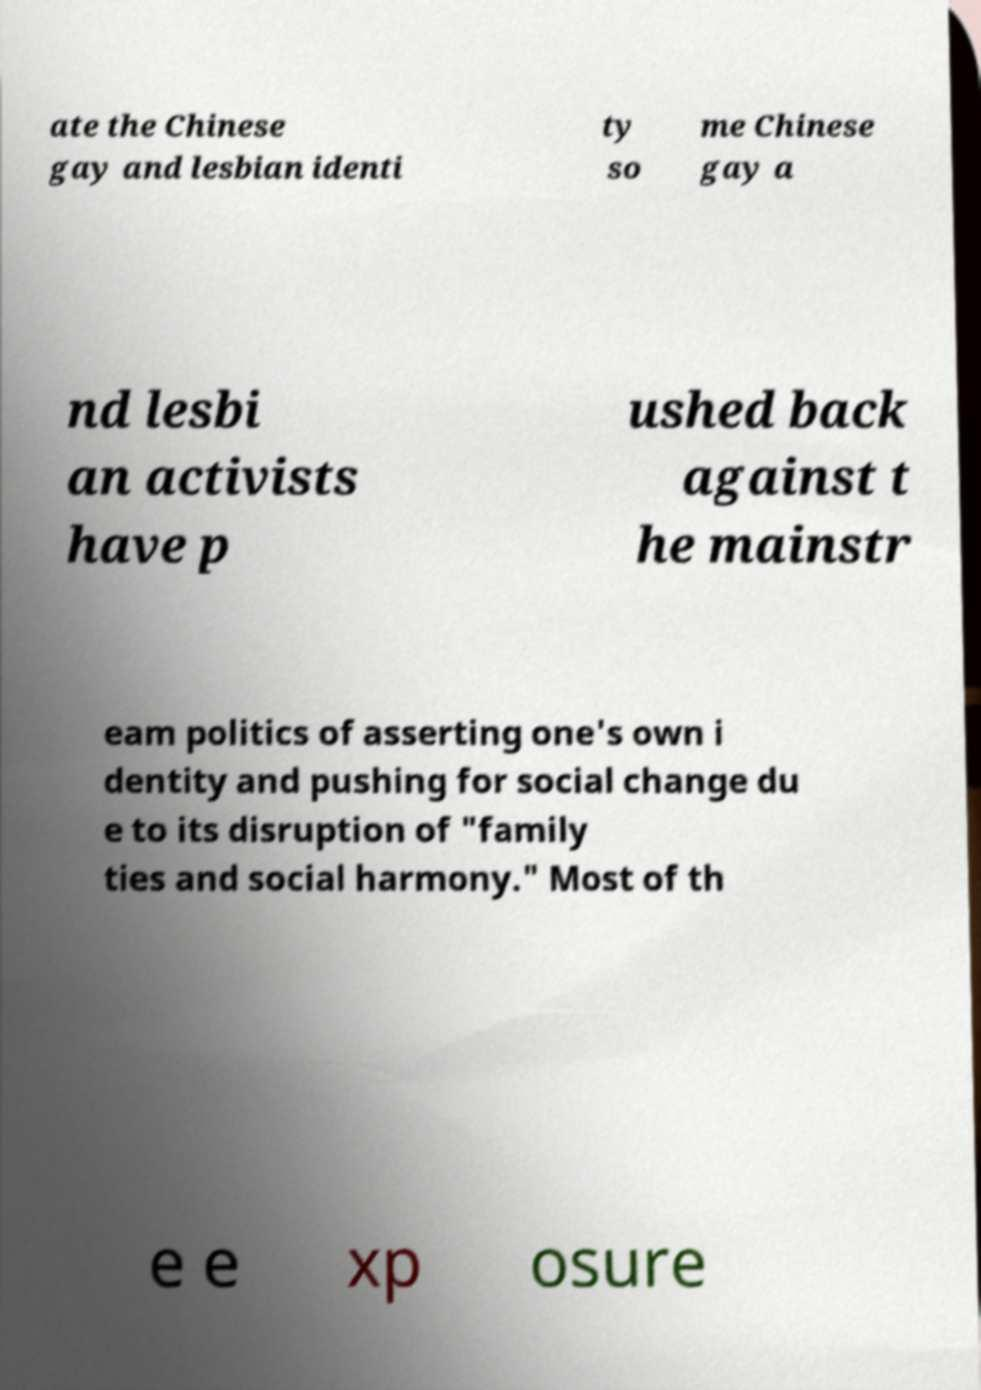Can you accurately transcribe the text from the provided image for me? ate the Chinese gay and lesbian identi ty so me Chinese gay a nd lesbi an activists have p ushed back against t he mainstr eam politics of asserting one's own i dentity and pushing for social change du e to its disruption of "family ties and social harmony." Most of th e e xp osure 